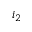<formula> <loc_0><loc_0><loc_500><loc_500>i _ { 2 }</formula> 